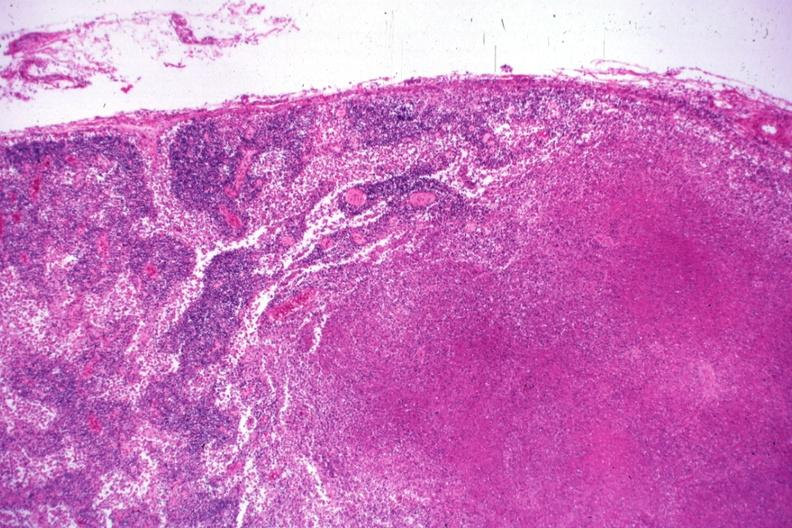s lymph node present?
Answer the question using a single word or phrase. Yes 